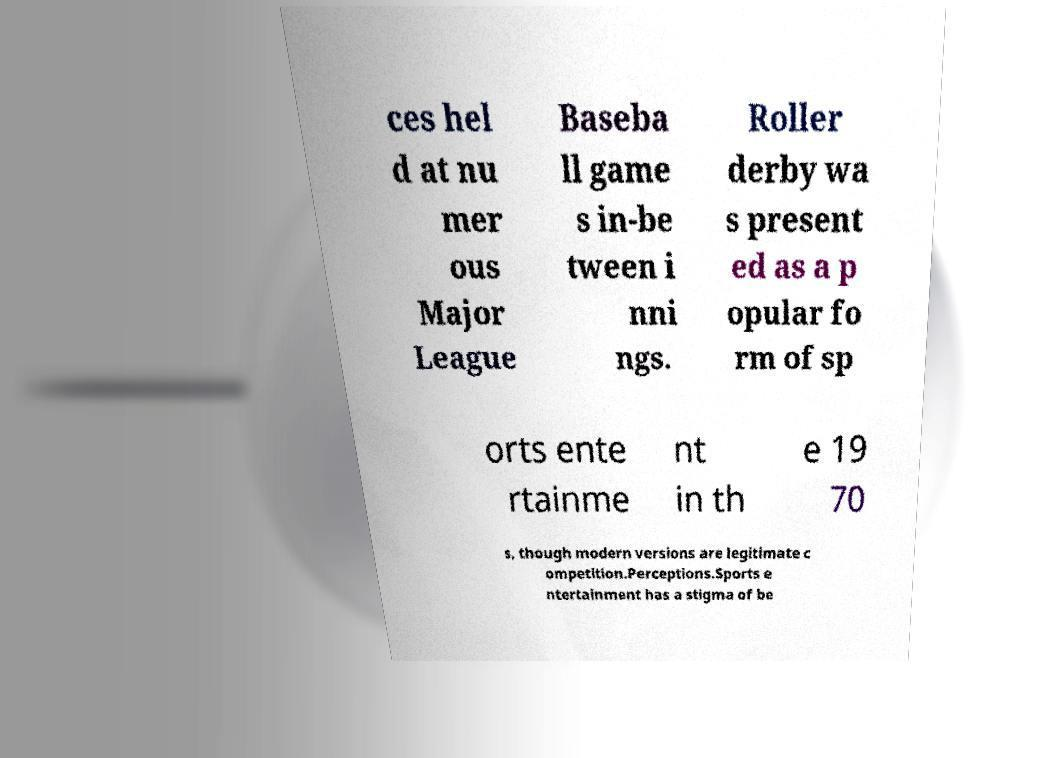Please read and relay the text visible in this image. What does it say? ces hel d at nu mer ous Major League Baseba ll game s in-be tween i nni ngs. Roller derby wa s present ed as a p opular fo rm of sp orts ente rtainme nt in th e 19 70 s, though modern versions are legitimate c ompetition.Perceptions.Sports e ntertainment has a stigma of be 